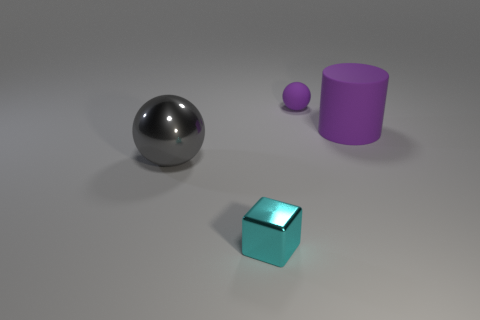Can you describe the colors of the objects in the image? Certainly! The image features a large metal ball with a reflective surface, a small purple sphere, a teal cube, and a lilac cylinder. The reflective surface of the metal ball displays muted reflections of the other objects and the environment. 